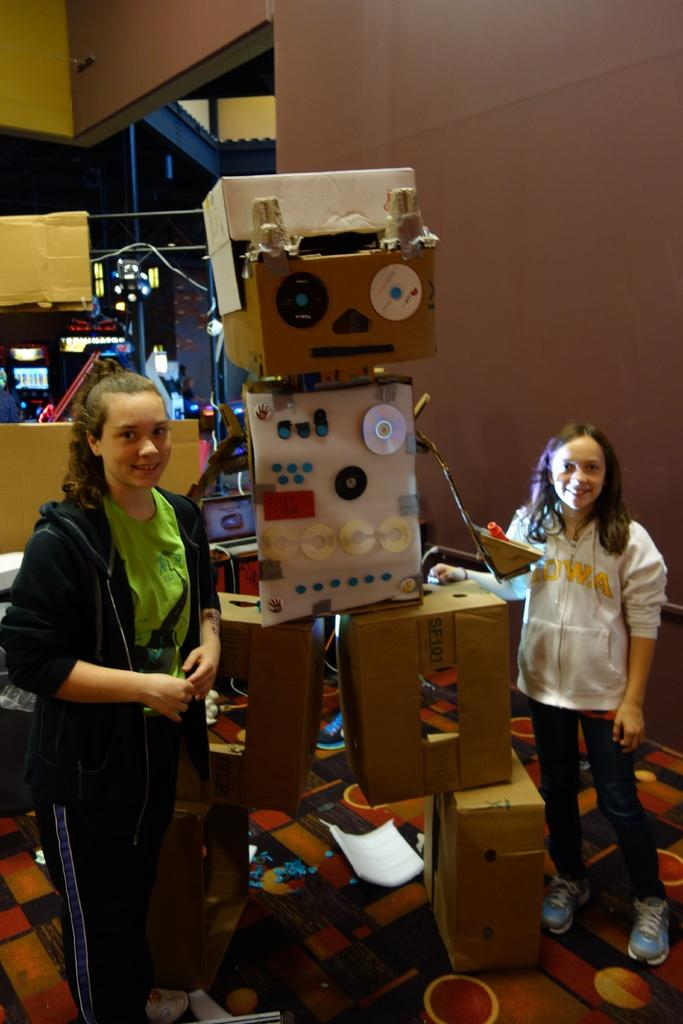How many girls are present in the image? There are two girls standing in the image. What can be seen in the image besides the girls? There is a robot made up of cartons and CD players in the image. What is located at the back of the image? There is a wall at the back in the image. What language are the girls speaking in the image? The provided facts do not mention the language the girls are speaking, so it cannot be determined from the image. 